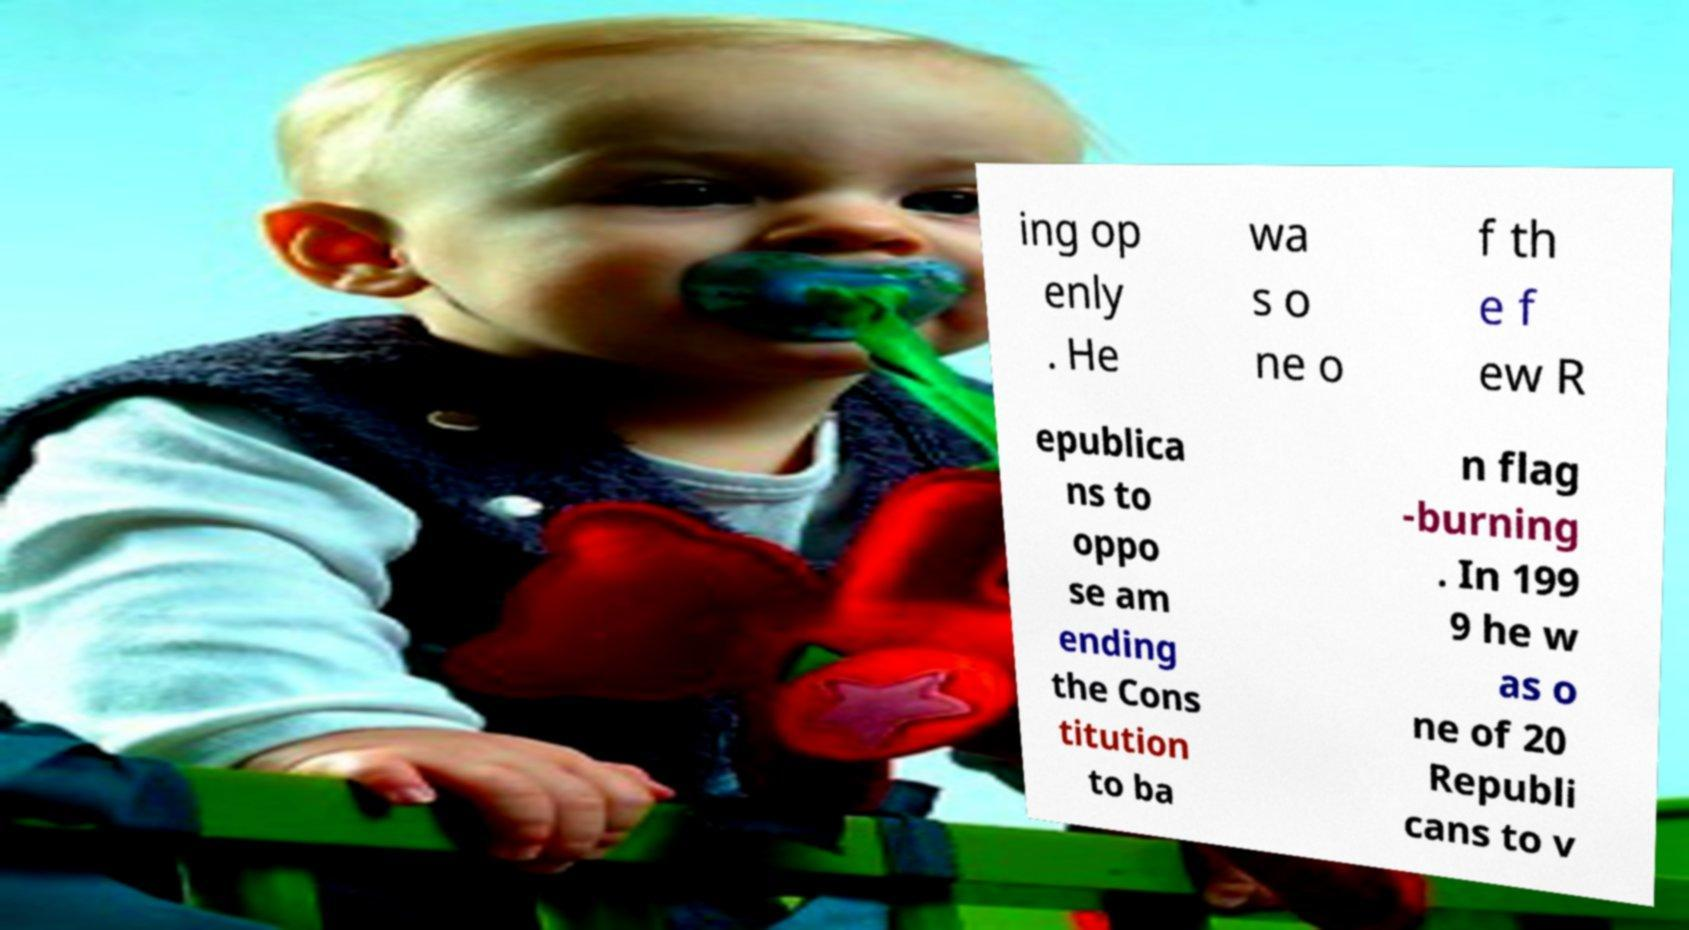Could you extract and type out the text from this image? ing op enly . He wa s o ne o f th e f ew R epublica ns to oppo se am ending the Cons titution to ba n flag -burning . In 199 9 he w as o ne of 20 Republi cans to v 